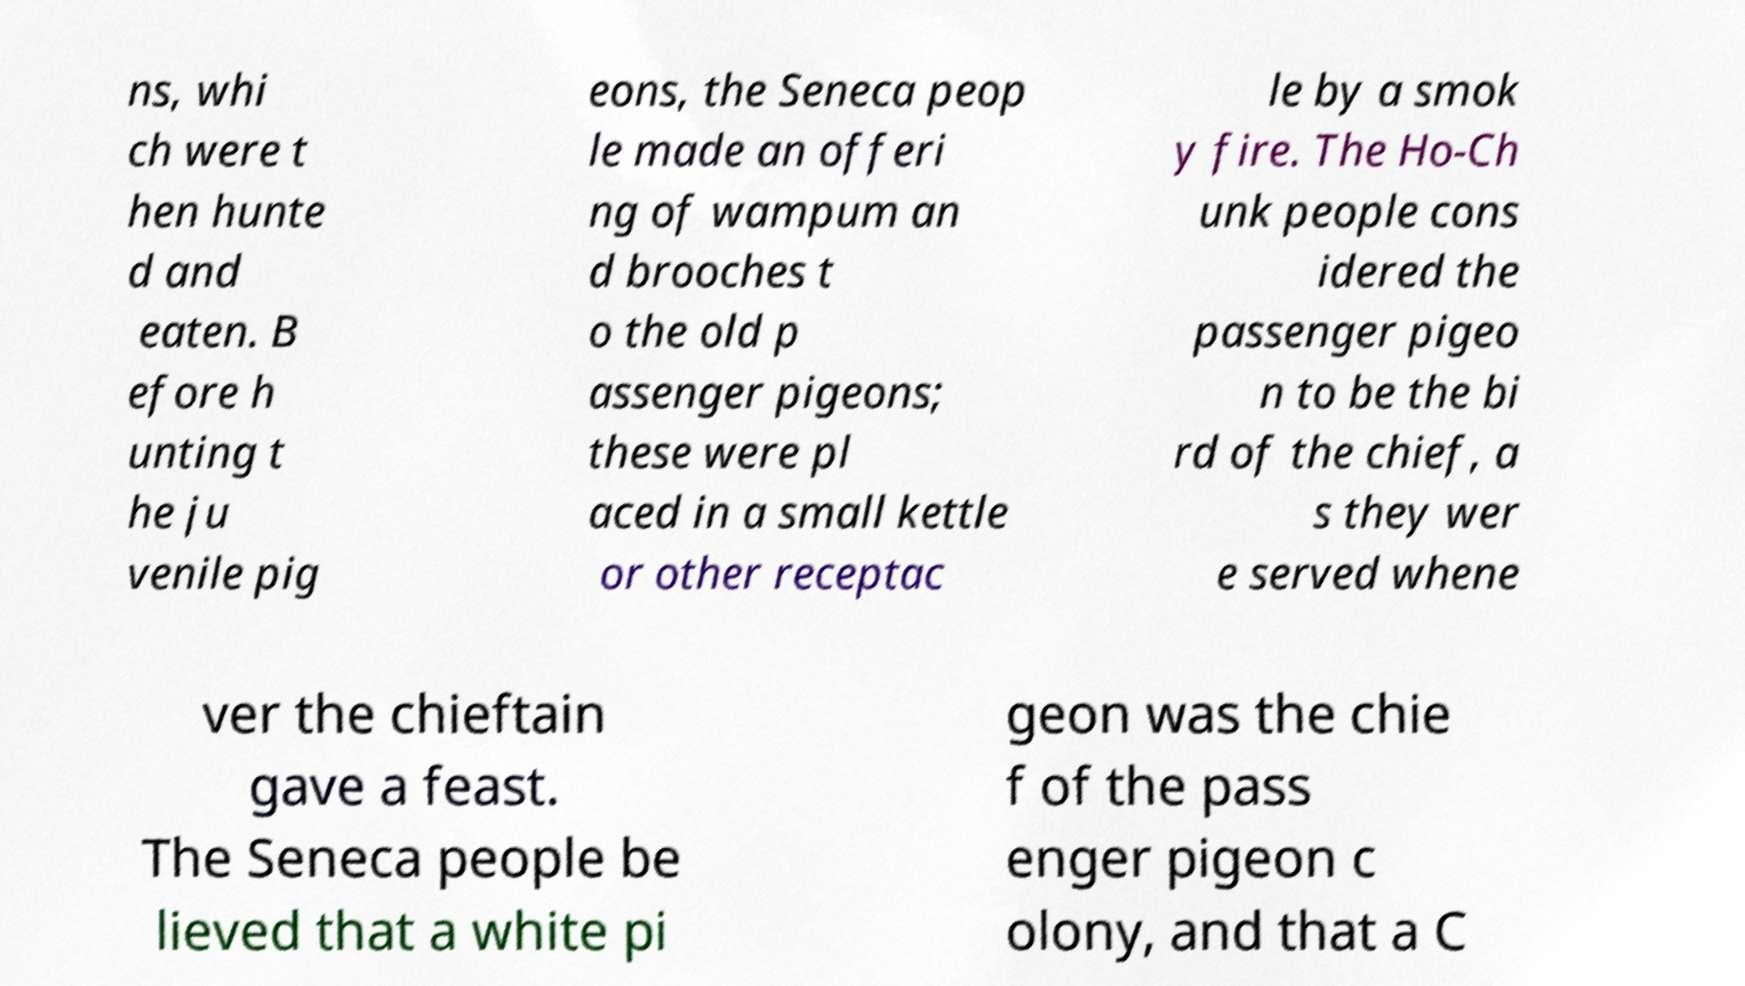I need the written content from this picture converted into text. Can you do that? ns, whi ch were t hen hunte d and eaten. B efore h unting t he ju venile pig eons, the Seneca peop le made an offeri ng of wampum an d brooches t o the old p assenger pigeons; these were pl aced in a small kettle or other receptac le by a smok y fire. The Ho-Ch unk people cons idered the passenger pigeo n to be the bi rd of the chief, a s they wer e served whene ver the chieftain gave a feast. The Seneca people be lieved that a white pi geon was the chie f of the pass enger pigeon c olony, and that a C 